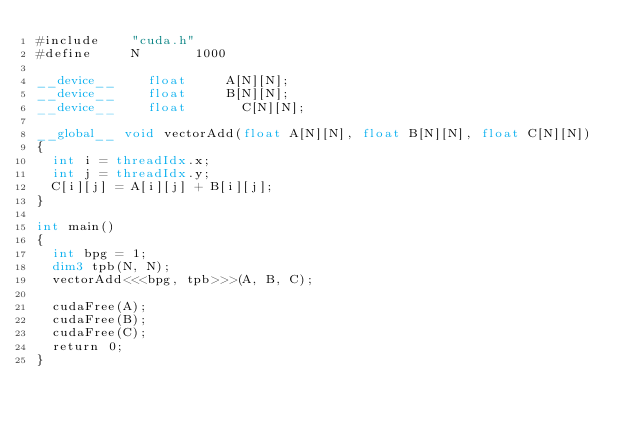<code> <loc_0><loc_0><loc_500><loc_500><_Cuda_>#include	  "cuda.h"
#define		  N			  1000

__device__	  float		  A[N][N];
__device__	  float		  B[N][N];
__device__    float       C[N][N];

__global__ void vectorAdd(float A[N][N], float B[N][N], float C[N][N])
{
	int i = threadIdx.x;
	int j = threadIdx.y;
	C[i][j] = A[i][j] + B[i][j];
}

int main()
{
	int bpg = 1;
	dim3 tpb(N, N);
	vectorAdd<<<bpg, tpb>>>(A, B, C);

	cudaFree(A);
	cudaFree(B);
	cudaFree(C);
	return 0;
}
</code> 